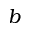<formula> <loc_0><loc_0><loc_500><loc_500>b</formula> 